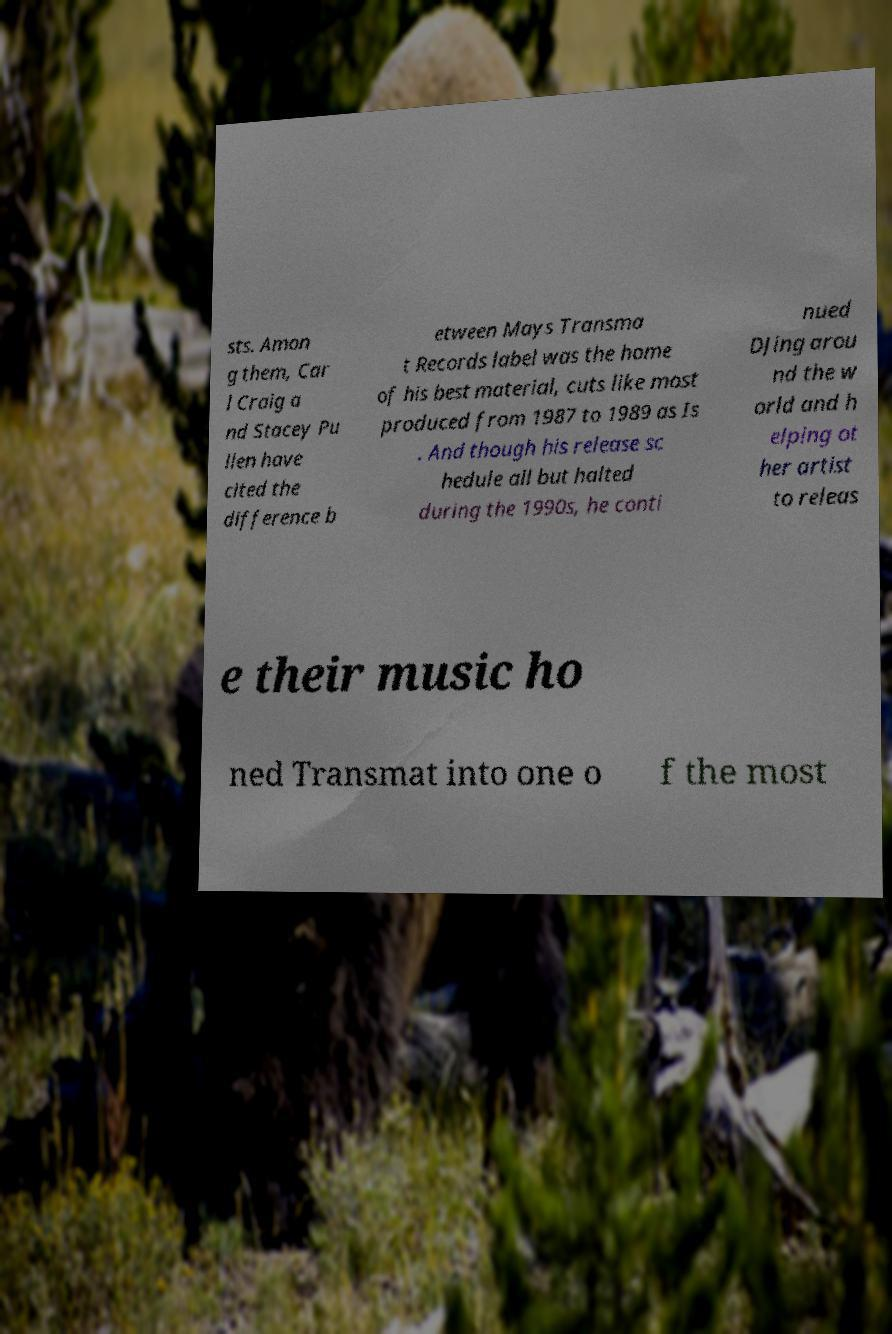Could you extract and type out the text from this image? sts. Amon g them, Car l Craig a nd Stacey Pu llen have cited the difference b etween Mays Transma t Records label was the home of his best material, cuts like most produced from 1987 to 1989 as Is . And though his release sc hedule all but halted during the 1990s, he conti nued DJing arou nd the w orld and h elping ot her artist to releas e their music ho ned Transmat into one o f the most 